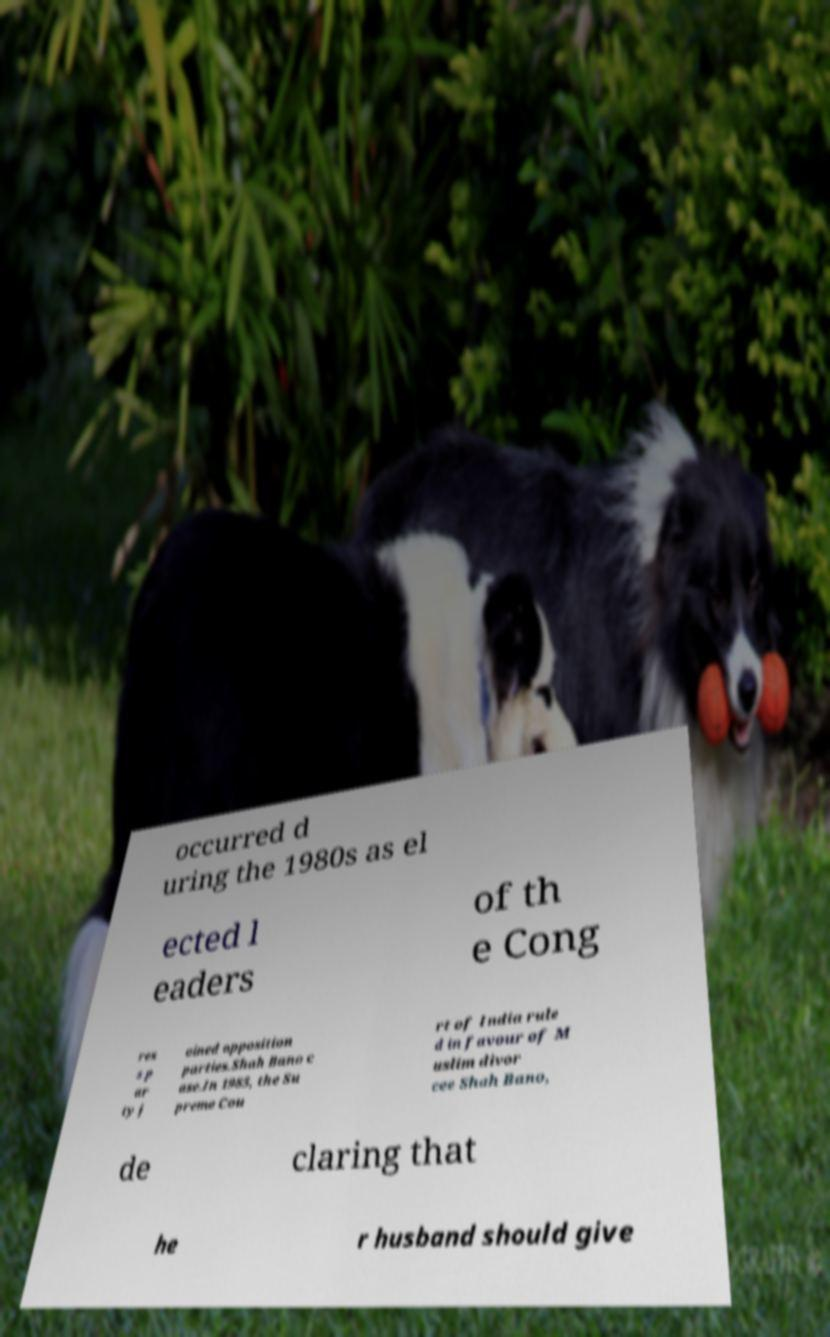There's text embedded in this image that I need extracted. Can you transcribe it verbatim? occurred d uring the 1980s as el ected l eaders of th e Cong res s p ar ty j oined opposition parties.Shah Bano c ase.In 1985, the Su preme Cou rt of India rule d in favour of M uslim divor cee Shah Bano, de claring that he r husband should give 